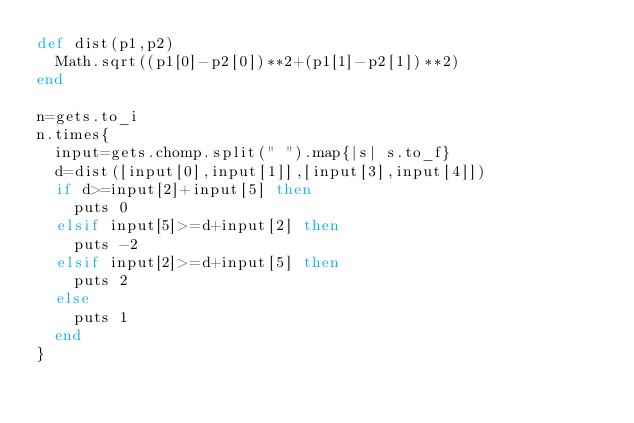<code> <loc_0><loc_0><loc_500><loc_500><_Ruby_>def dist(p1,p2)
	Math.sqrt((p1[0]-p2[0])**2+(p1[1]-p2[1])**2)
end

n=gets.to_i
n.times{
	input=gets.chomp.split(" ").map{|s| s.to_f}
	d=dist([input[0],input[1]],[input[3],input[4]])
	if d>=input[2]+input[5] then
		puts 0
	elsif input[5]>=d+input[2] then
		puts -2
	elsif input[2]>=d+input[5] then
		puts 2
	else
		puts 1
	end
}
</code> 